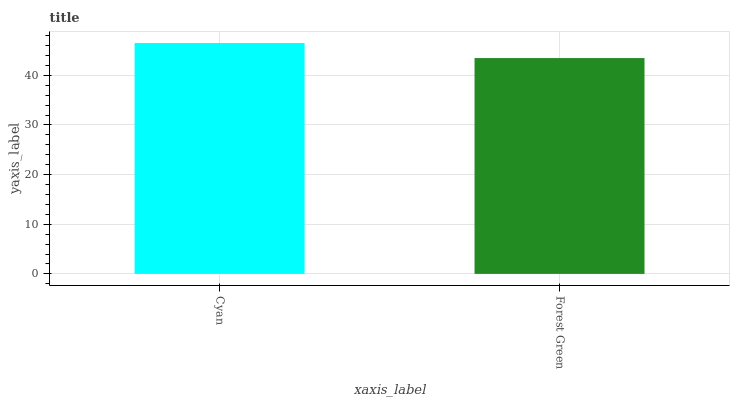Is Forest Green the minimum?
Answer yes or no. Yes. Is Cyan the maximum?
Answer yes or no. Yes. Is Forest Green the maximum?
Answer yes or no. No. Is Cyan greater than Forest Green?
Answer yes or no. Yes. Is Forest Green less than Cyan?
Answer yes or no. Yes. Is Forest Green greater than Cyan?
Answer yes or no. No. Is Cyan less than Forest Green?
Answer yes or no. No. Is Cyan the high median?
Answer yes or no. Yes. Is Forest Green the low median?
Answer yes or no. Yes. Is Forest Green the high median?
Answer yes or no. No. Is Cyan the low median?
Answer yes or no. No. 